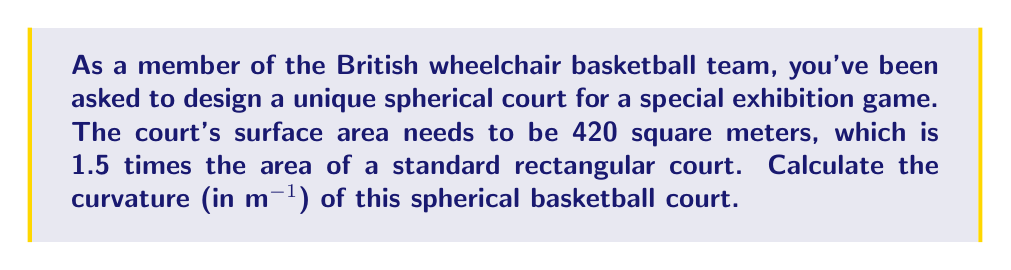Can you answer this question? Let's approach this step-by-step:

1) First, we need to find the radius of the spherical court. We know the surface area is 420 m².

2) The formula for the surface area of a sphere is:
   $$ A = 4\pi r^2 $$
   where $A$ is the surface area and $r$ is the radius.

3) Substituting our known value:
   $$ 420 = 4\pi r^2 $$

4) Solving for $r$:
   $$ r^2 = \frac{420}{4\pi} $$
   $$ r = \sqrt{\frac{420}{4\pi}} \approx 5.78 \text{ m} $$

5) Now, we need to calculate the curvature. In non-Euclidean geometry, the curvature of a sphere is given by:
   $$ K = \frac{1}{r^2} $$
   where $K$ is the Gaussian curvature and $r$ is the radius.

6) Substituting our calculated radius:
   $$ K = \frac{1}{(5.78)^2} \approx 0.0299 \text{ m}^{-2} $$

7) However, the question asks for curvature in m^(-1), which is actually the reciprocal of the radius:
   $$ \text{Curvature} = \frac{1}{r} = \frac{1}{5.78} \approx 0.173 \text{ m}^{-1} $$
Answer: $0.173 \text{ m}^{-1}$ 